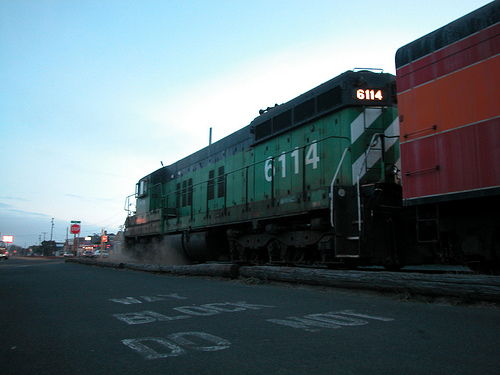Imagine the train is part of a storybook. What adventure might this train be on? In this storybook adventure, the green train, named 'Emerald Express', embarks on a magical journey to the Land of Lights. Directed by an enchanted conductor, the train's mission is to collect the scattered fragments of the legendary Prism Stone, which has the power to restore balance to the magical realms. Throughout its journey, the train encounters various mystical creatures, passing through enchanted forests, luminous caves, and soaring over moonlit mountains. 